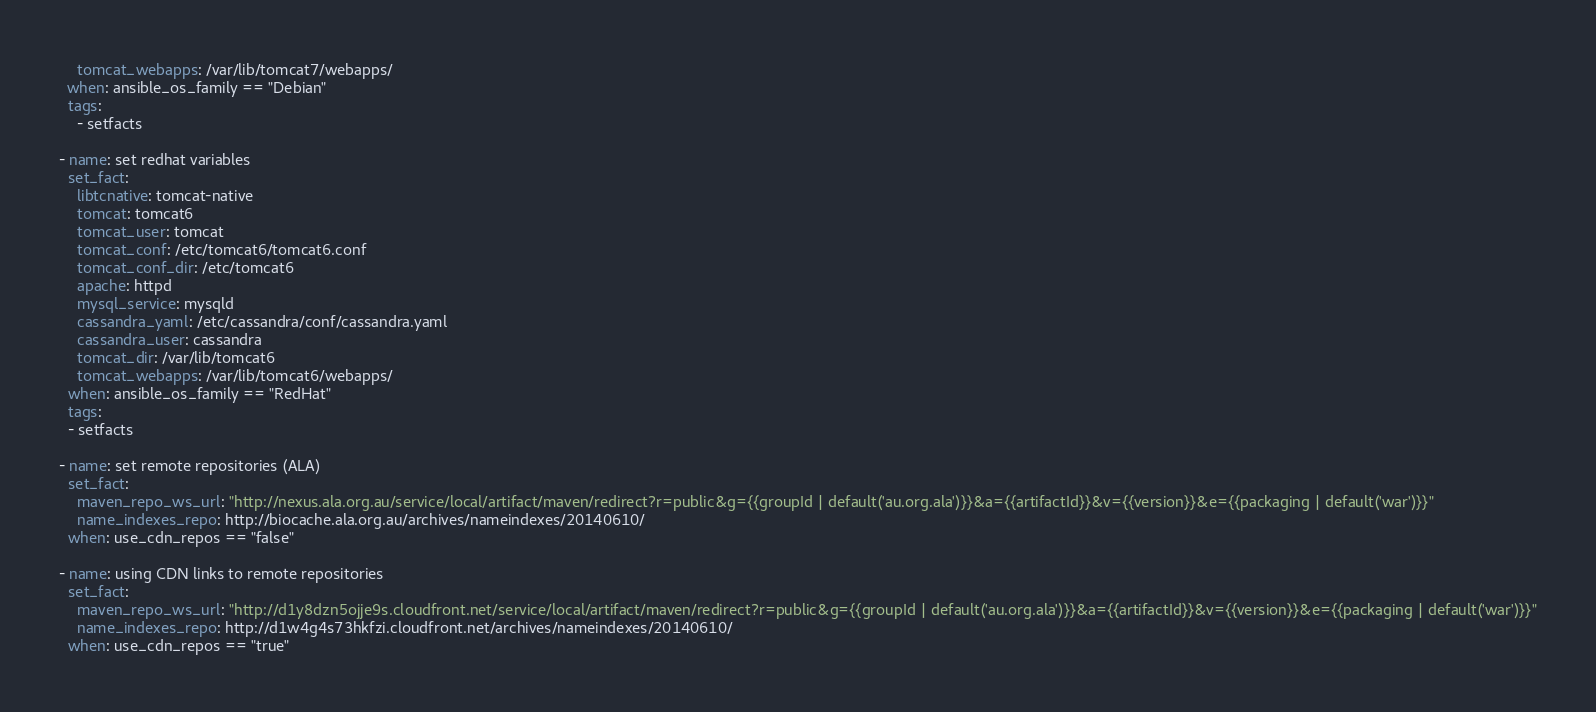Convert code to text. <code><loc_0><loc_0><loc_500><loc_500><_YAML_>    tomcat_webapps: /var/lib/tomcat7/webapps/
  when: ansible_os_family == "Debian"
  tags:
    - setfacts

- name: set redhat variables
  set_fact:
    libtcnative: tomcat-native
    tomcat: tomcat6
    tomcat_user: tomcat
    tomcat_conf: /etc/tomcat6/tomcat6.conf 
    tomcat_conf_dir: /etc/tomcat6
    apache: httpd
    mysql_service: mysqld
    cassandra_yaml: /etc/cassandra/conf/cassandra.yaml
    cassandra_user: cassandra
    tomcat_dir: /var/lib/tomcat6
    tomcat_webapps: /var/lib/tomcat6/webapps/
  when: ansible_os_family == "RedHat"
  tags:
  - setfacts

- name: set remote repositories (ALA)
  set_fact:
    maven_repo_ws_url: "http://nexus.ala.org.au/service/local/artifact/maven/redirect?r=public&g={{groupId | default('au.org.ala')}}&a={{artifactId}}&v={{version}}&e={{packaging | default('war')}}"
    name_indexes_repo: http://biocache.ala.org.au/archives/nameindexes/20140610/
  when: use_cdn_repos == "false"

- name: using CDN links to remote repositories 
  set_fact:
    maven_repo_ws_url: "http://d1y8dzn5ojje9s.cloudfront.net/service/local/artifact/maven/redirect?r=public&g={{groupId | default('au.org.ala')}}&a={{artifactId}}&v={{version}}&e={{packaging | default('war')}}"
    name_indexes_repo: http://d1w4g4s73hkfzi.cloudfront.net/archives/nameindexes/20140610/
  when: use_cdn_repos == "true"</code> 